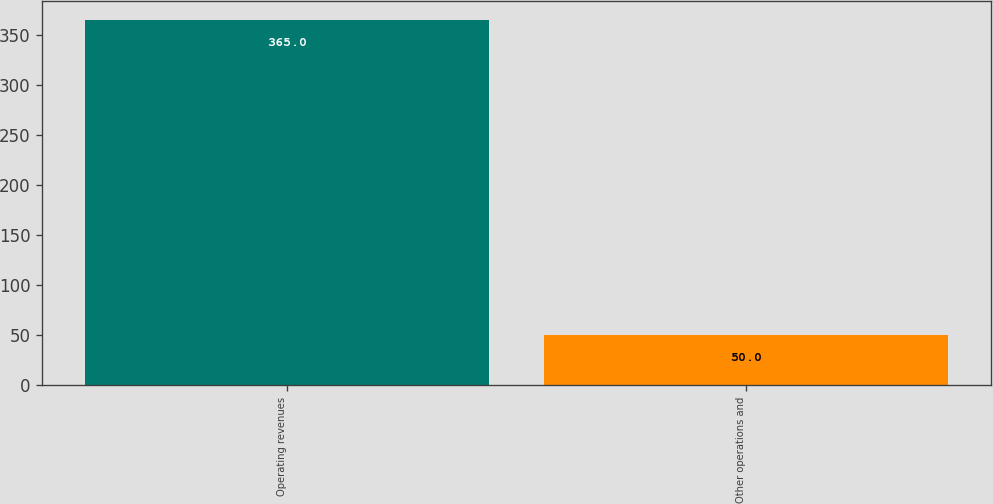<chart> <loc_0><loc_0><loc_500><loc_500><bar_chart><fcel>Operating revenues<fcel>Other operations and<nl><fcel>365<fcel>50<nl></chart> 